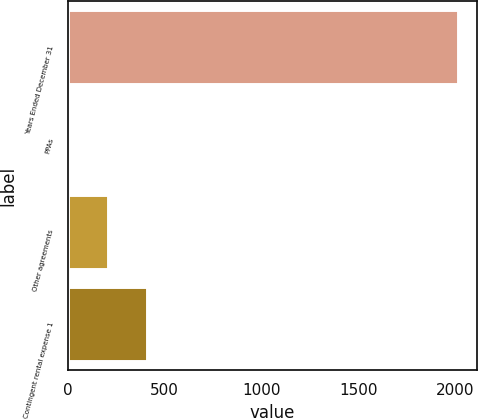<chart> <loc_0><loc_0><loc_500><loc_500><bar_chart><fcel>Years Ended December 31<fcel>PPAs<fcel>Other agreements<fcel>Contingent rental expense 1<nl><fcel>2013<fcel>6<fcel>206.7<fcel>407.4<nl></chart> 